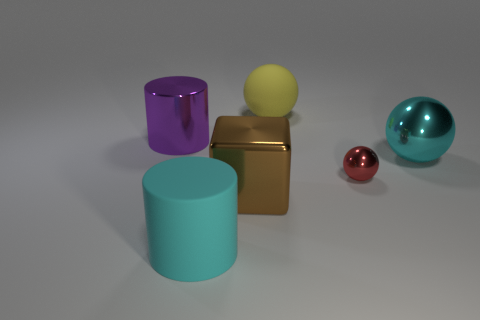Subtract all small spheres. How many spheres are left? 2 Subtract 1 spheres. How many spheres are left? 2 Add 1 cyan rubber objects. How many objects exist? 7 Subtract all cylinders. How many objects are left? 4 Subtract all green balls. Subtract all cyan cubes. How many balls are left? 3 Subtract all large yellow rubber objects. Subtract all metal balls. How many objects are left? 3 Add 5 red things. How many red things are left? 6 Add 4 rubber blocks. How many rubber blocks exist? 4 Subtract 1 red spheres. How many objects are left? 5 